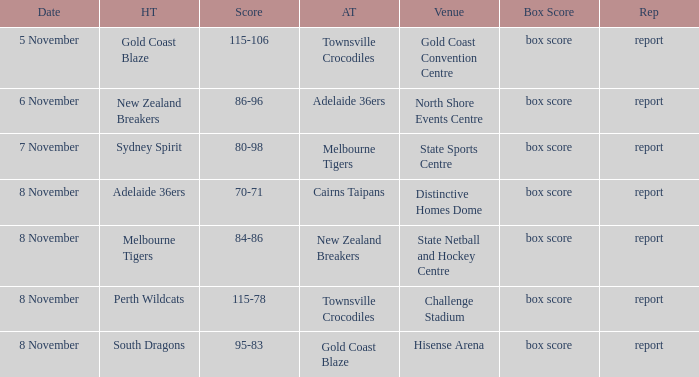What was the date that featured a game against Gold Coast Blaze? 8 November. 